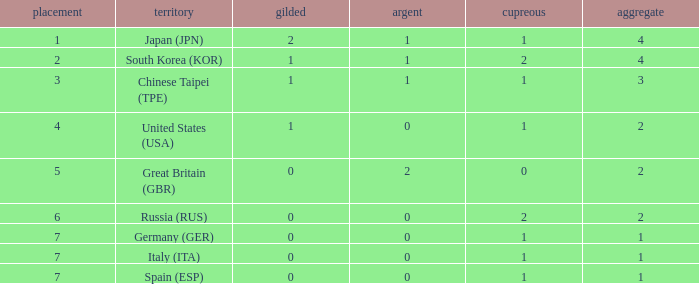How many total medals does a country with more than 1 silver medals have? 2.0. 